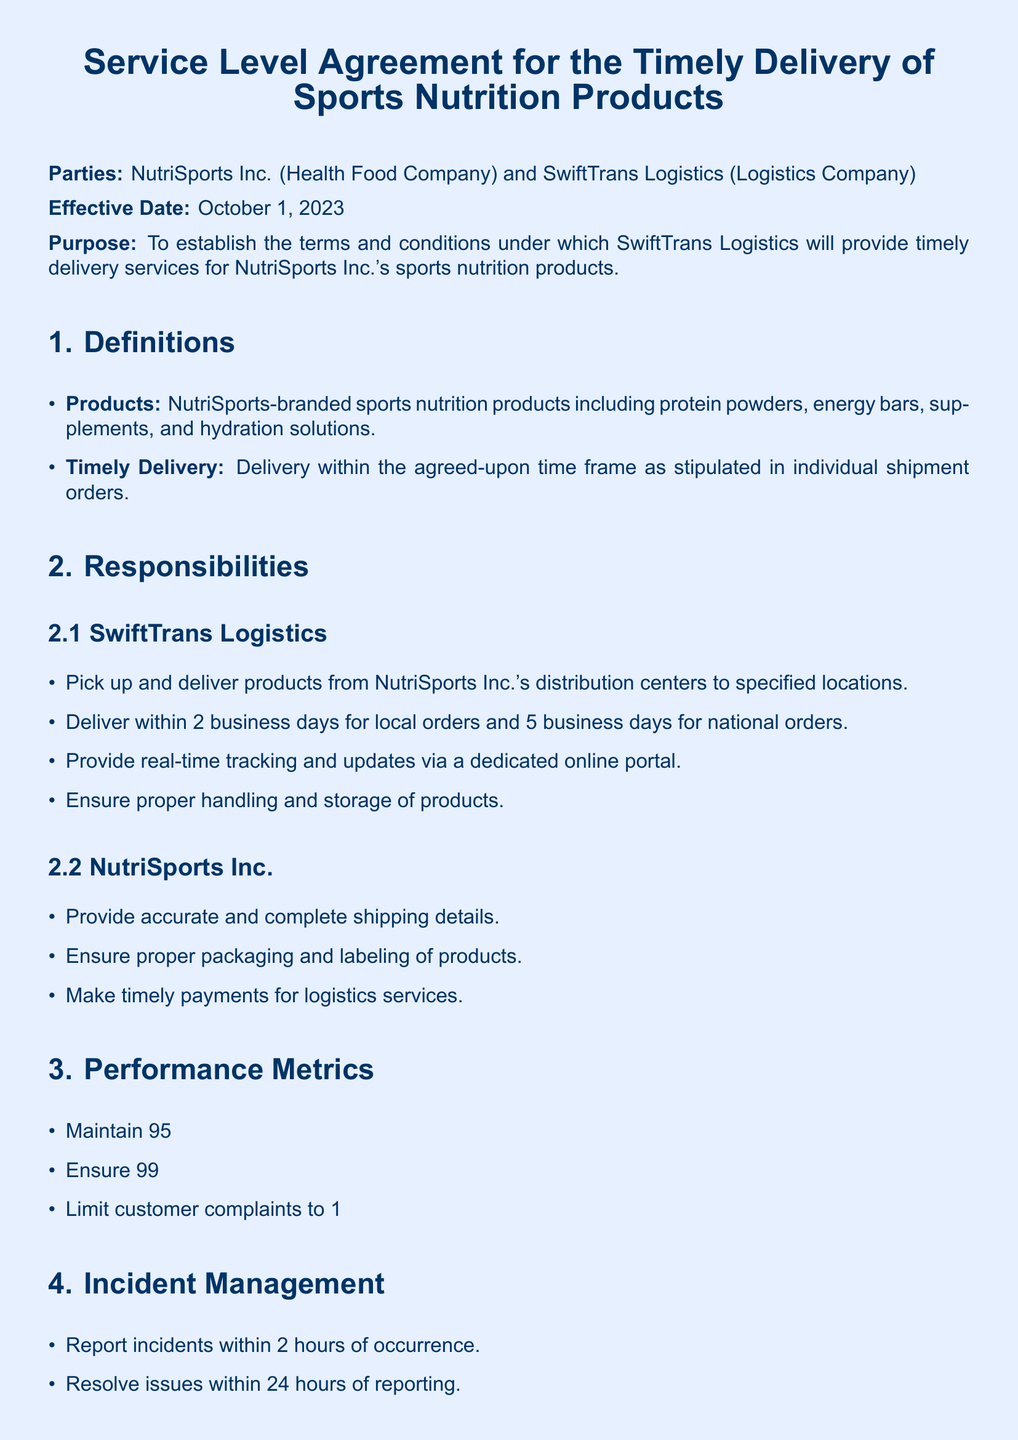What is the effective date of the agreement? The effective date is the date when the agreement becomes active, which is October 1, 2023.
Answer: October 1, 2023 Who are the parties involved in this agreement? The parties involved are the two entities entering into the contract, which are NutriSports Inc. and SwiftTrans Logistics.
Answer: NutriSports Inc. and SwiftTrans Logistics What is the on-time delivery rate required per month? This refers to the performance metric that must be met by SwiftTrans Logistics, which is stated in the document.
Answer: 95% How long is the delivery period for local orders? This specifies the maximum time allocated for local deliveries as outlined in the responsibilities of SwiftTrans Logistics.
Answer: 2 business days What is the limit on customer complaints per month? This is a performance metric that indicates how many complaints can be registered without breaching the agreement.
Answer: 1% What must SwiftTrans Logistics ensure regarding product handling? This refers to the duty of care that SwiftTrans Logistics must uphold for the products during transit.
Answer: Proper handling and storage What is required for termination of the agreement? This outlines the procedural requirement for either party wishing to end the contract.
Answer: 30-day written notice What should happen if an incident occurs? This describes the response required from SwiftTrans Logistics when an incident happens, according to the incident management section.
Answer: Report incidents within 2 hours What does the confidentiality clause address? This is a specific section of the agreement that pertains to the protection of sensitive information shared between the parties.
Answer: Maintain confidentiality and adhere to data privacy laws 